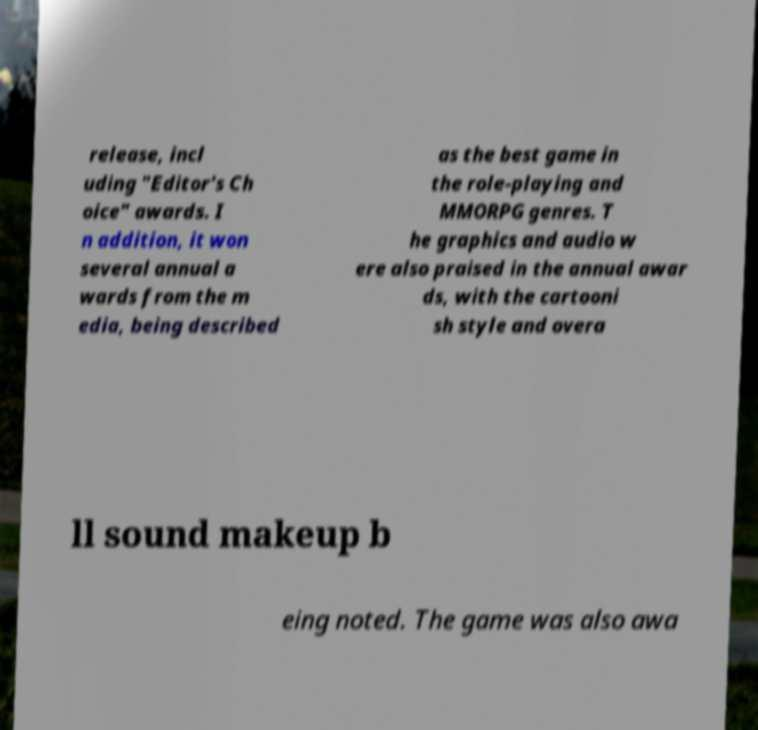I need the written content from this picture converted into text. Can you do that? release, incl uding "Editor's Ch oice" awards. I n addition, it won several annual a wards from the m edia, being described as the best game in the role-playing and MMORPG genres. T he graphics and audio w ere also praised in the annual awar ds, with the cartooni sh style and overa ll sound makeup b eing noted. The game was also awa 